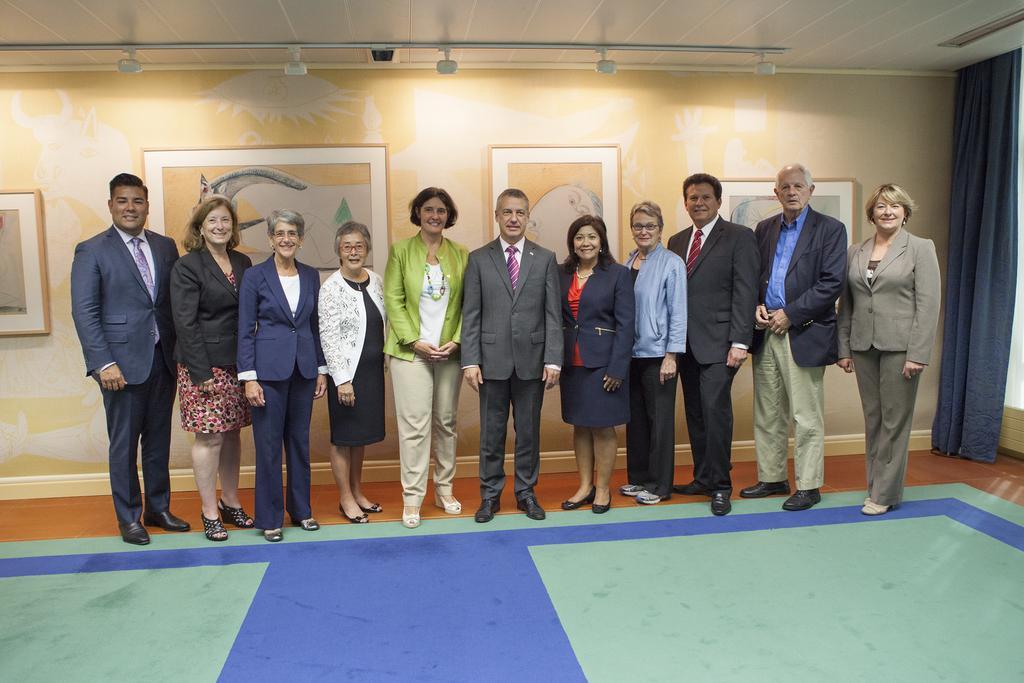Please provide a concise description of this image. As we can see in the image there are group of people standing, wall, photo frames, mat and a curtain. 